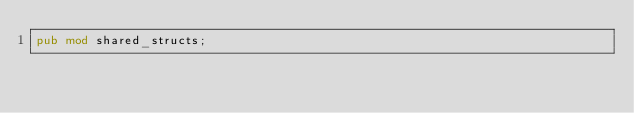<code> <loc_0><loc_0><loc_500><loc_500><_Rust_>pub mod shared_structs;</code> 